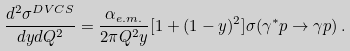Convert formula to latex. <formula><loc_0><loc_0><loc_500><loc_500>\frac { d ^ { 2 } \sigma ^ { D V C S } } { d y d Q ^ { 2 } } = \frac { \alpha _ { e . m . } } { 2 \pi Q ^ { 2 } y } [ 1 + ( 1 - y ) ^ { 2 } ] \sigma ( \gamma ^ { * } p \rightarrow \gamma p ) \, .</formula> 